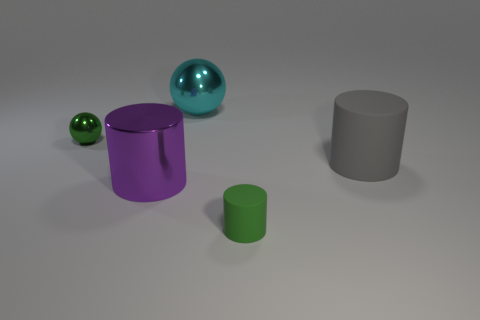Can you describe the colors and shapes of the objects present in the image? Certainly! The image showcases four objects, each with a distinct color and shape. On the left, there's a vivid purple cylinder with a missing segment, resembling a 'C' shape. Beside it lies a smaller green cylinder. Toward the right, there’s a large teal sphere with a reflective surface, and further to its right is a large gray cylinder with a matte surface. Are there any patterns or textures on any of these objects? There aren't any visible patterns or textures on the objects; they all appear to have smooth, uniform surfaces. The teal sphere has a reflective quality that gives it a shiny appearance, while the other objects possess more of a matte finish. 